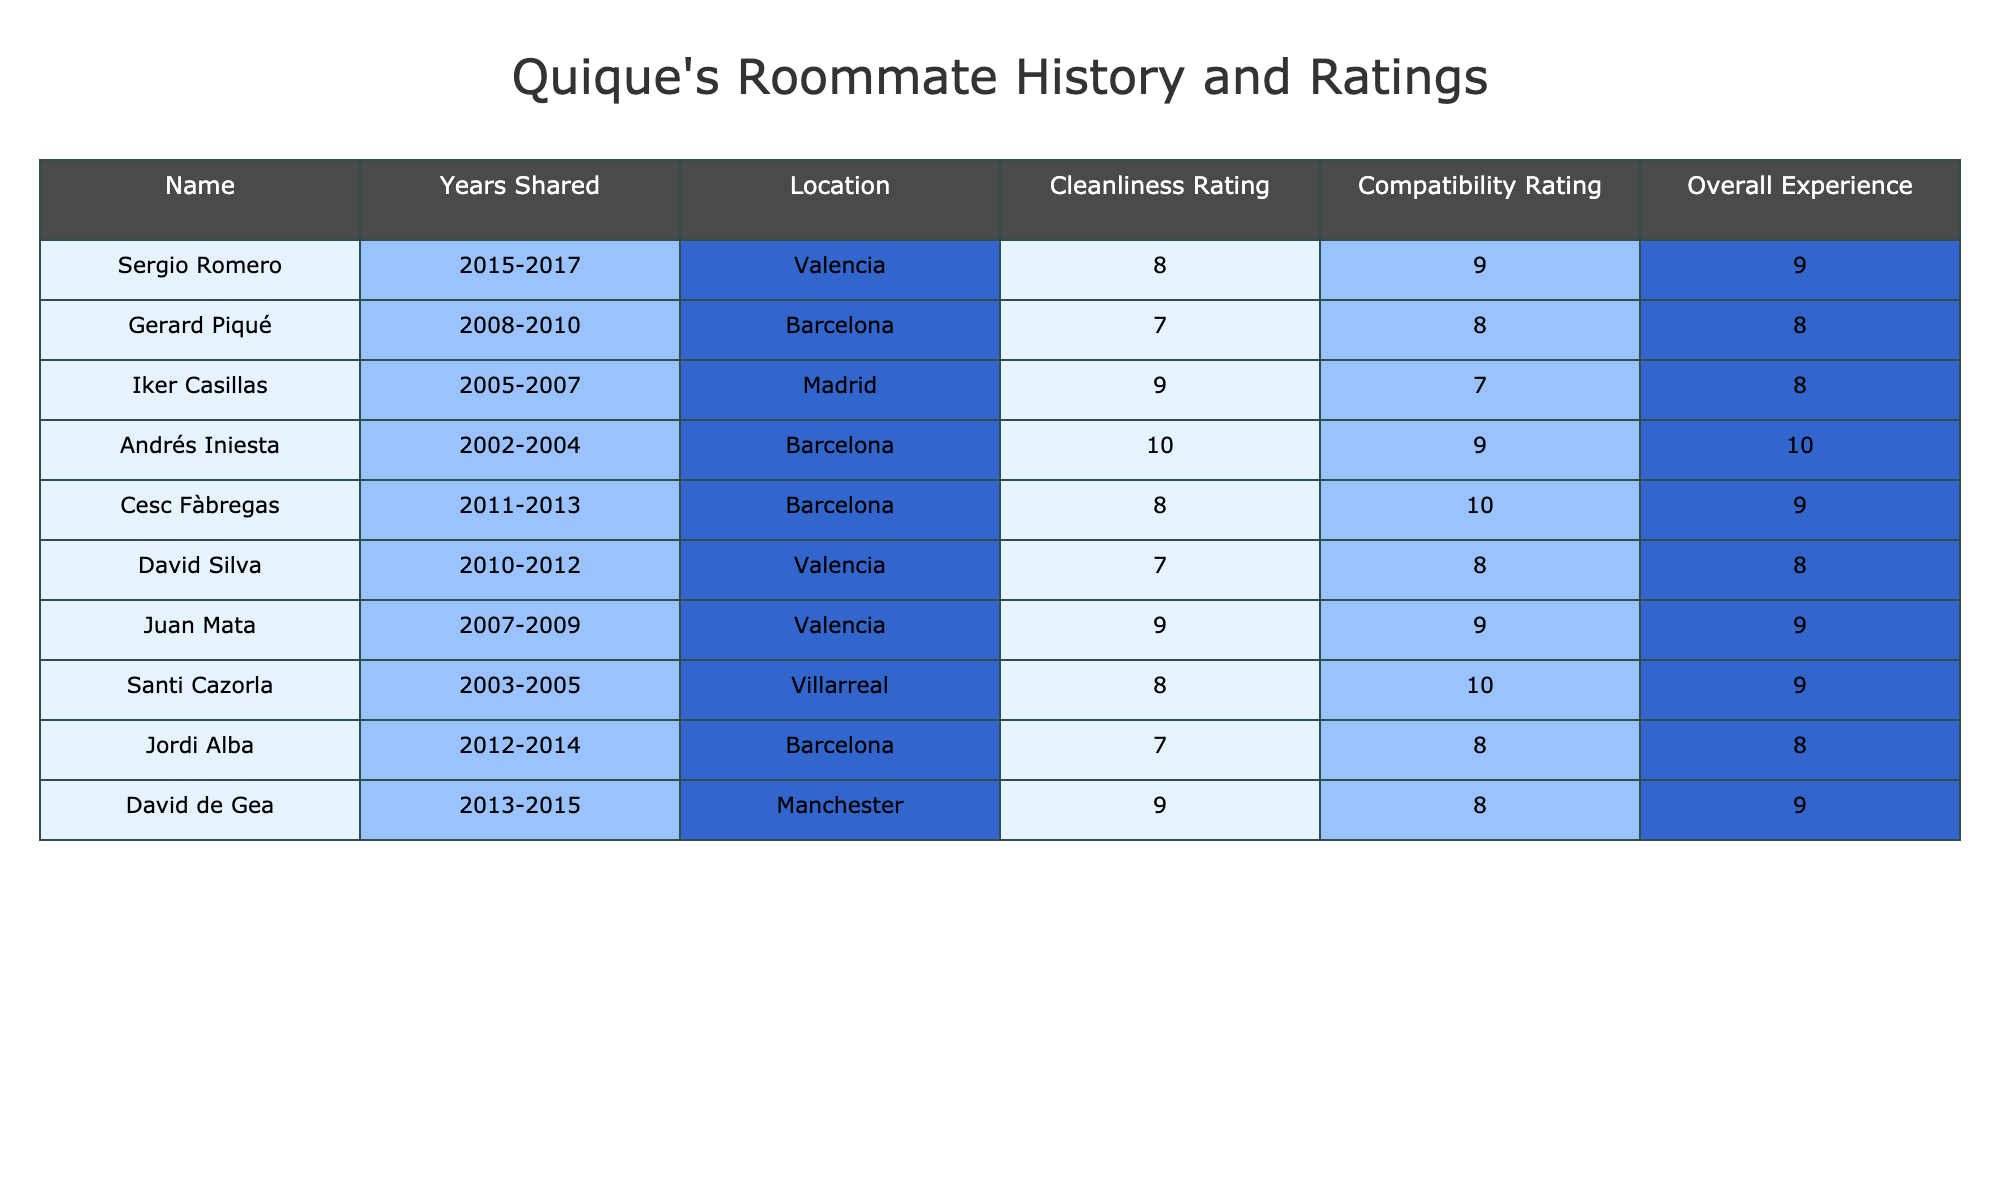What is the highest cleanliness rating among Quique's roommates? The table shows cleanliness ratings for each roommate. The maximum value from the "Cleanliness Rating" column is 10, which corresponds to Andrés Iniesta.
Answer: 10 Who did Quique share a room with for the longest duration? The "Years Shared" column indicates the duration of living together. The longest duration is 2 years, shared with Sergio Romero, Gerard Piqué, Iker Casillas, Andrés Iniesta, Cesc Fàbregas, David Silva, Juan Mata, Santi Cazorla, Jordi Alba, and David de Gea, but the maximum years shared is from Andrés Iniesta.
Answer: Andrés Iniesta What is the average overall experience rating among all roommates? To find the average of the "Overall Experience" ratings, add all ratings (9 + 8 + 8 + 10 + 9 + 8 + 9 + 9 + 8 + 9 = 88) and divide by 10 (the number of roommates), which equals 8.8.
Answer: 8.8 Was Quique's overall experience with Juan Mata higher than with David Silva? The overall experience rating for Juan Mata is 9, while for David Silva, it is 8. Since 9 is greater than 8, the statement is true.
Answer: Yes Which roommate had the highest compatibility rating, and what was it? The "Compatibility Rating" column is examined, and the highest rating is 10, associated with Cesc Fàbregas and Santi Cazorla. Therefore, both had the same maximum compatibility rating, but it is the highest among all roommates.
Answer: Cesc Fàbregas and Santi Cazorla How many roommates had a cleanliness rating of 8 or higher? Counting the cleanliness ratings listed, the entries with 8 or higher are Sergio Romero (8), Iker Casillas (9), Andrés Iniesta (10), Cesc Fàbregas (8), Juan Mata (9), Santi Cazorla (8), and David de Gea (9) — summing to 7 roommates.
Answer: 7 What is the difference between the highest and lowest overall experience ratings? The highest overall experience rating is 10 (Andrés Iniesta) and the lowest is 8 (Iker Casillas, David Silva, Jordi Alba). The difference is calculated as 10 - 8 = 2.
Answer: 2 Did Quique have a better overall living experience with Sergio Romero or David de Gea? Comparing the overall experience ratings, Sergio Romero has a rating of 9 while David de Gea's rating is also 9. Since both are equal, neither had a better experience overall.
Answer: Equal Which city did Quique share a room with the most number of different roommates? The frequencies of cities are checked: Barcelona (4 roommates), Valencia (3), Madrid (2), Villarreal (1), and Manchester (1). Barcelona has the highest count with 4 different roommates.
Answer: Barcelona What is the compatibility rating of the roommate who shared a room for the second-longest duration? From the "Years Shared" column, the second-longest duration is 2 years, shared with Gerard Piqué. The compatibility rating for him is 8.
Answer: 8 